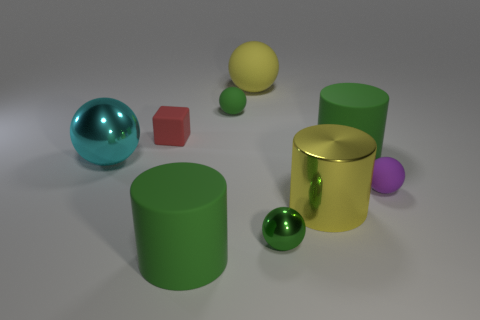Subtract all purple balls. How many balls are left? 4 Subtract all large matte spheres. How many spheres are left? 4 Subtract all red spheres. Subtract all gray cylinders. How many spheres are left? 5 Add 1 purple rubber balls. How many objects exist? 10 Subtract all blocks. How many objects are left? 8 Subtract all cyan things. Subtract all yellow rubber things. How many objects are left? 7 Add 4 red blocks. How many red blocks are left? 5 Add 3 tiny spheres. How many tiny spheres exist? 6 Subtract 0 brown spheres. How many objects are left? 9 